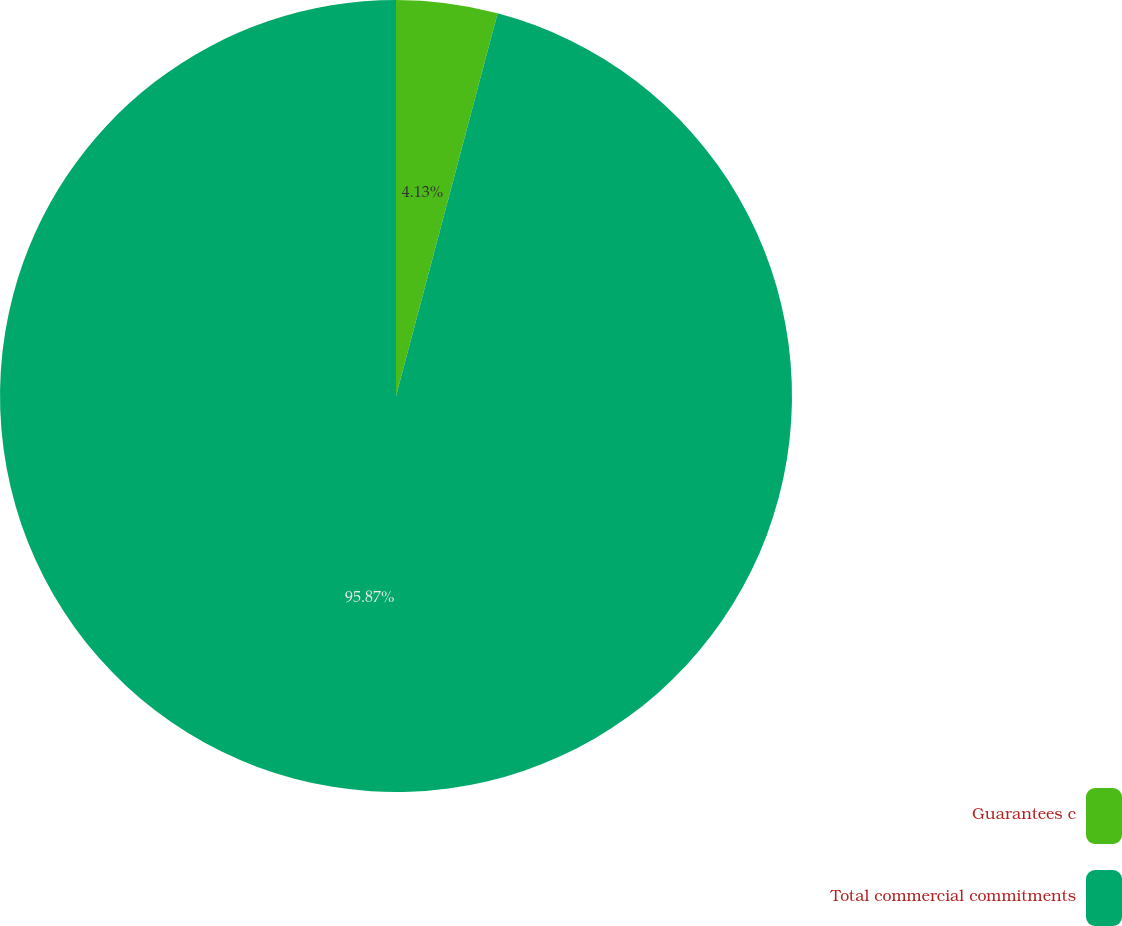Convert chart. <chart><loc_0><loc_0><loc_500><loc_500><pie_chart><fcel>Guarantees c<fcel>Total commercial commitments<nl><fcel>4.13%<fcel>95.87%<nl></chart> 